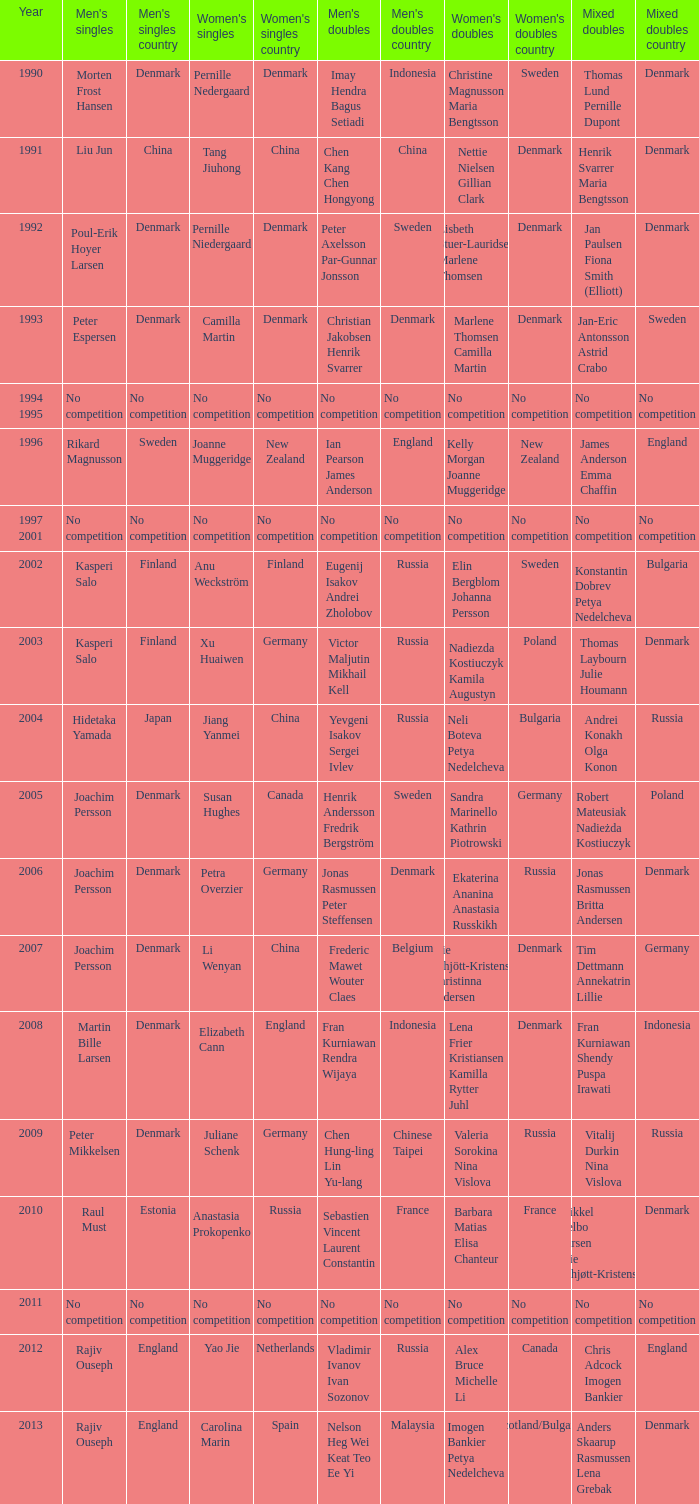When juliane schenk claimed victory in the women's singles, who were the mixed doubles winners? Vitalij Durkin Nina Vislova. 